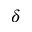<formula> <loc_0><loc_0><loc_500><loc_500>\delta</formula> 